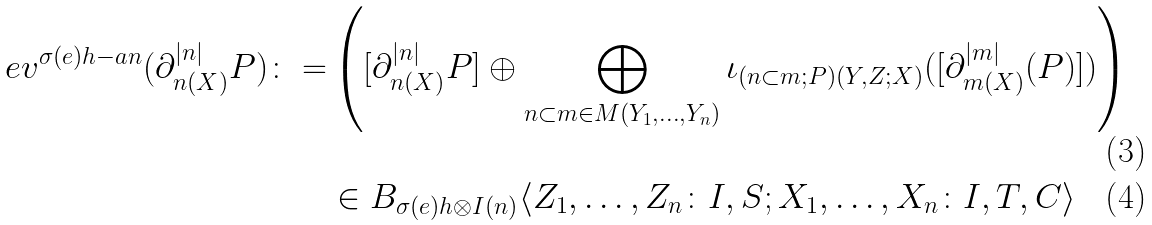<formula> <loc_0><loc_0><loc_500><loc_500>e v ^ { \sigma ( e ) h - a n } ( \partial ^ { | n | } _ { n ( X ) } P ) \colon = & \left ( [ \partial ^ { | n | } _ { n ( X ) } P ] \oplus \bigoplus _ { n \subset m \in M ( Y _ { 1 } , \dots , Y _ { n } ) } \iota _ { ( n \subset m ; P ) ( Y , Z ; X ) } ( [ \partial ^ { | m | } _ { m ( X ) } ( P ) ] ) \right ) \\ & \in B _ { \sigma ( e ) h \otimes I ( n ) } \langle Z _ { 1 } , \dots , Z _ { n } \colon I , S ; X _ { 1 } , \dots , X _ { n } \colon I , T , C \rangle</formula> 